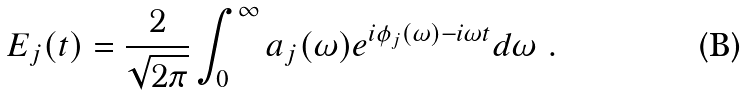<formula> <loc_0><loc_0><loc_500><loc_500>E _ { j } ( t ) = \frac { 2 } { \sqrt { 2 \pi } } \int _ { 0 } ^ { \infty } a _ { j } ( \omega ) e ^ { i \phi _ { j } ( \omega ) - i \omega t } d \omega \ .</formula> 